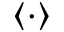Convert formula to latex. <formula><loc_0><loc_0><loc_500><loc_500>\left \langle \cdot \right \rangle</formula> 